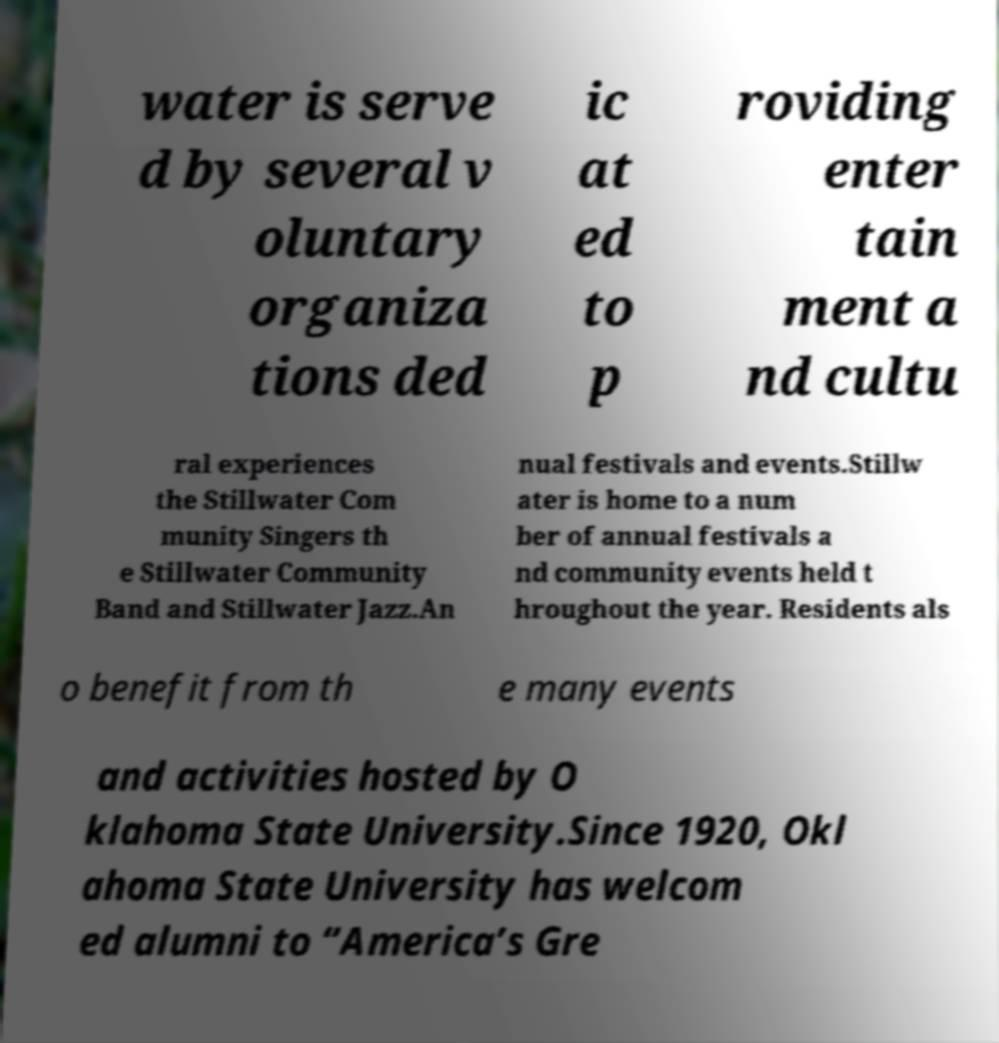Could you extract and type out the text from this image? water is serve d by several v oluntary organiza tions ded ic at ed to p roviding enter tain ment a nd cultu ral experiences the Stillwater Com munity Singers th e Stillwater Community Band and Stillwater Jazz.An nual festivals and events.Stillw ater is home to a num ber of annual festivals a nd community events held t hroughout the year. Residents als o benefit from th e many events and activities hosted by O klahoma State University.Since 1920, Okl ahoma State University has welcom ed alumni to “America’s Gre 